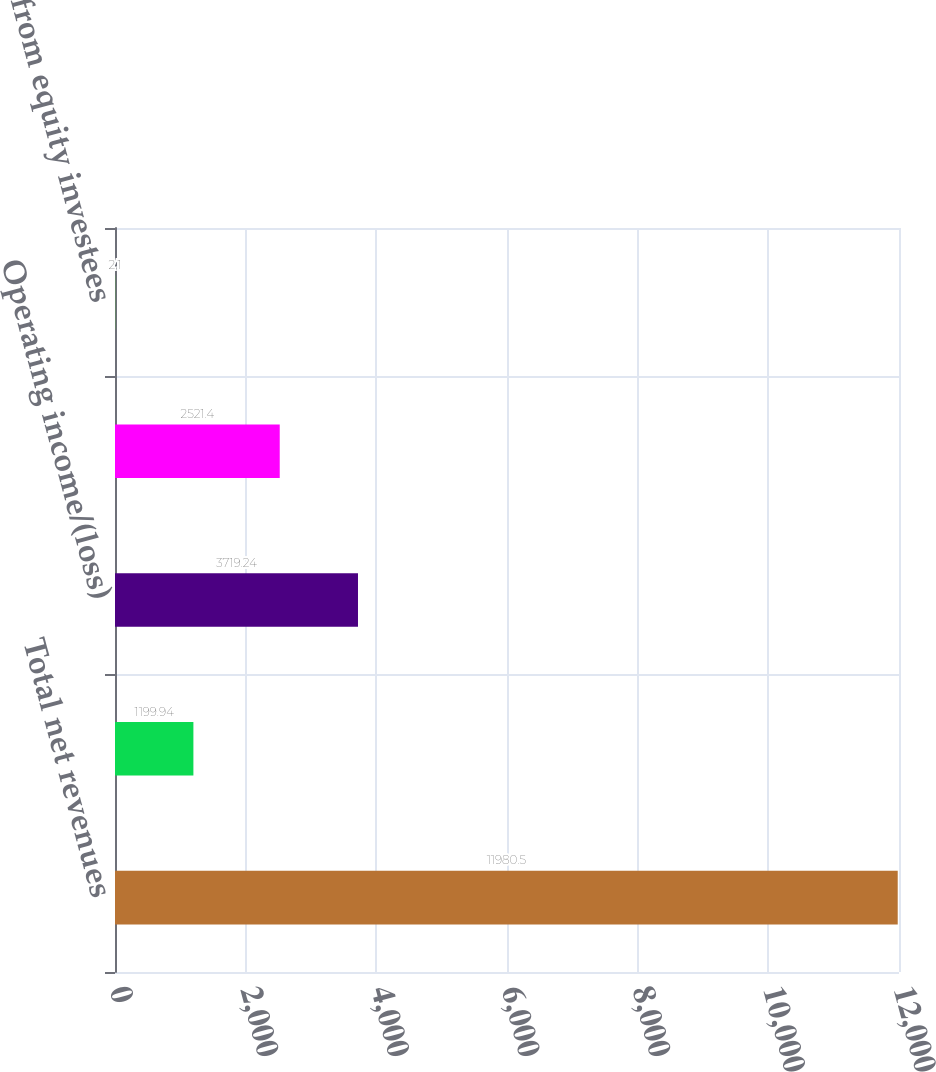Convert chart to OTSL. <chart><loc_0><loc_0><loc_500><loc_500><bar_chart><fcel>Total net revenues<fcel>Depreciation and amortization<fcel>Operating income/(loss)<fcel>Total assets<fcel>Income from equity investees<nl><fcel>11980.5<fcel>1199.94<fcel>3719.24<fcel>2521.4<fcel>2.1<nl></chart> 